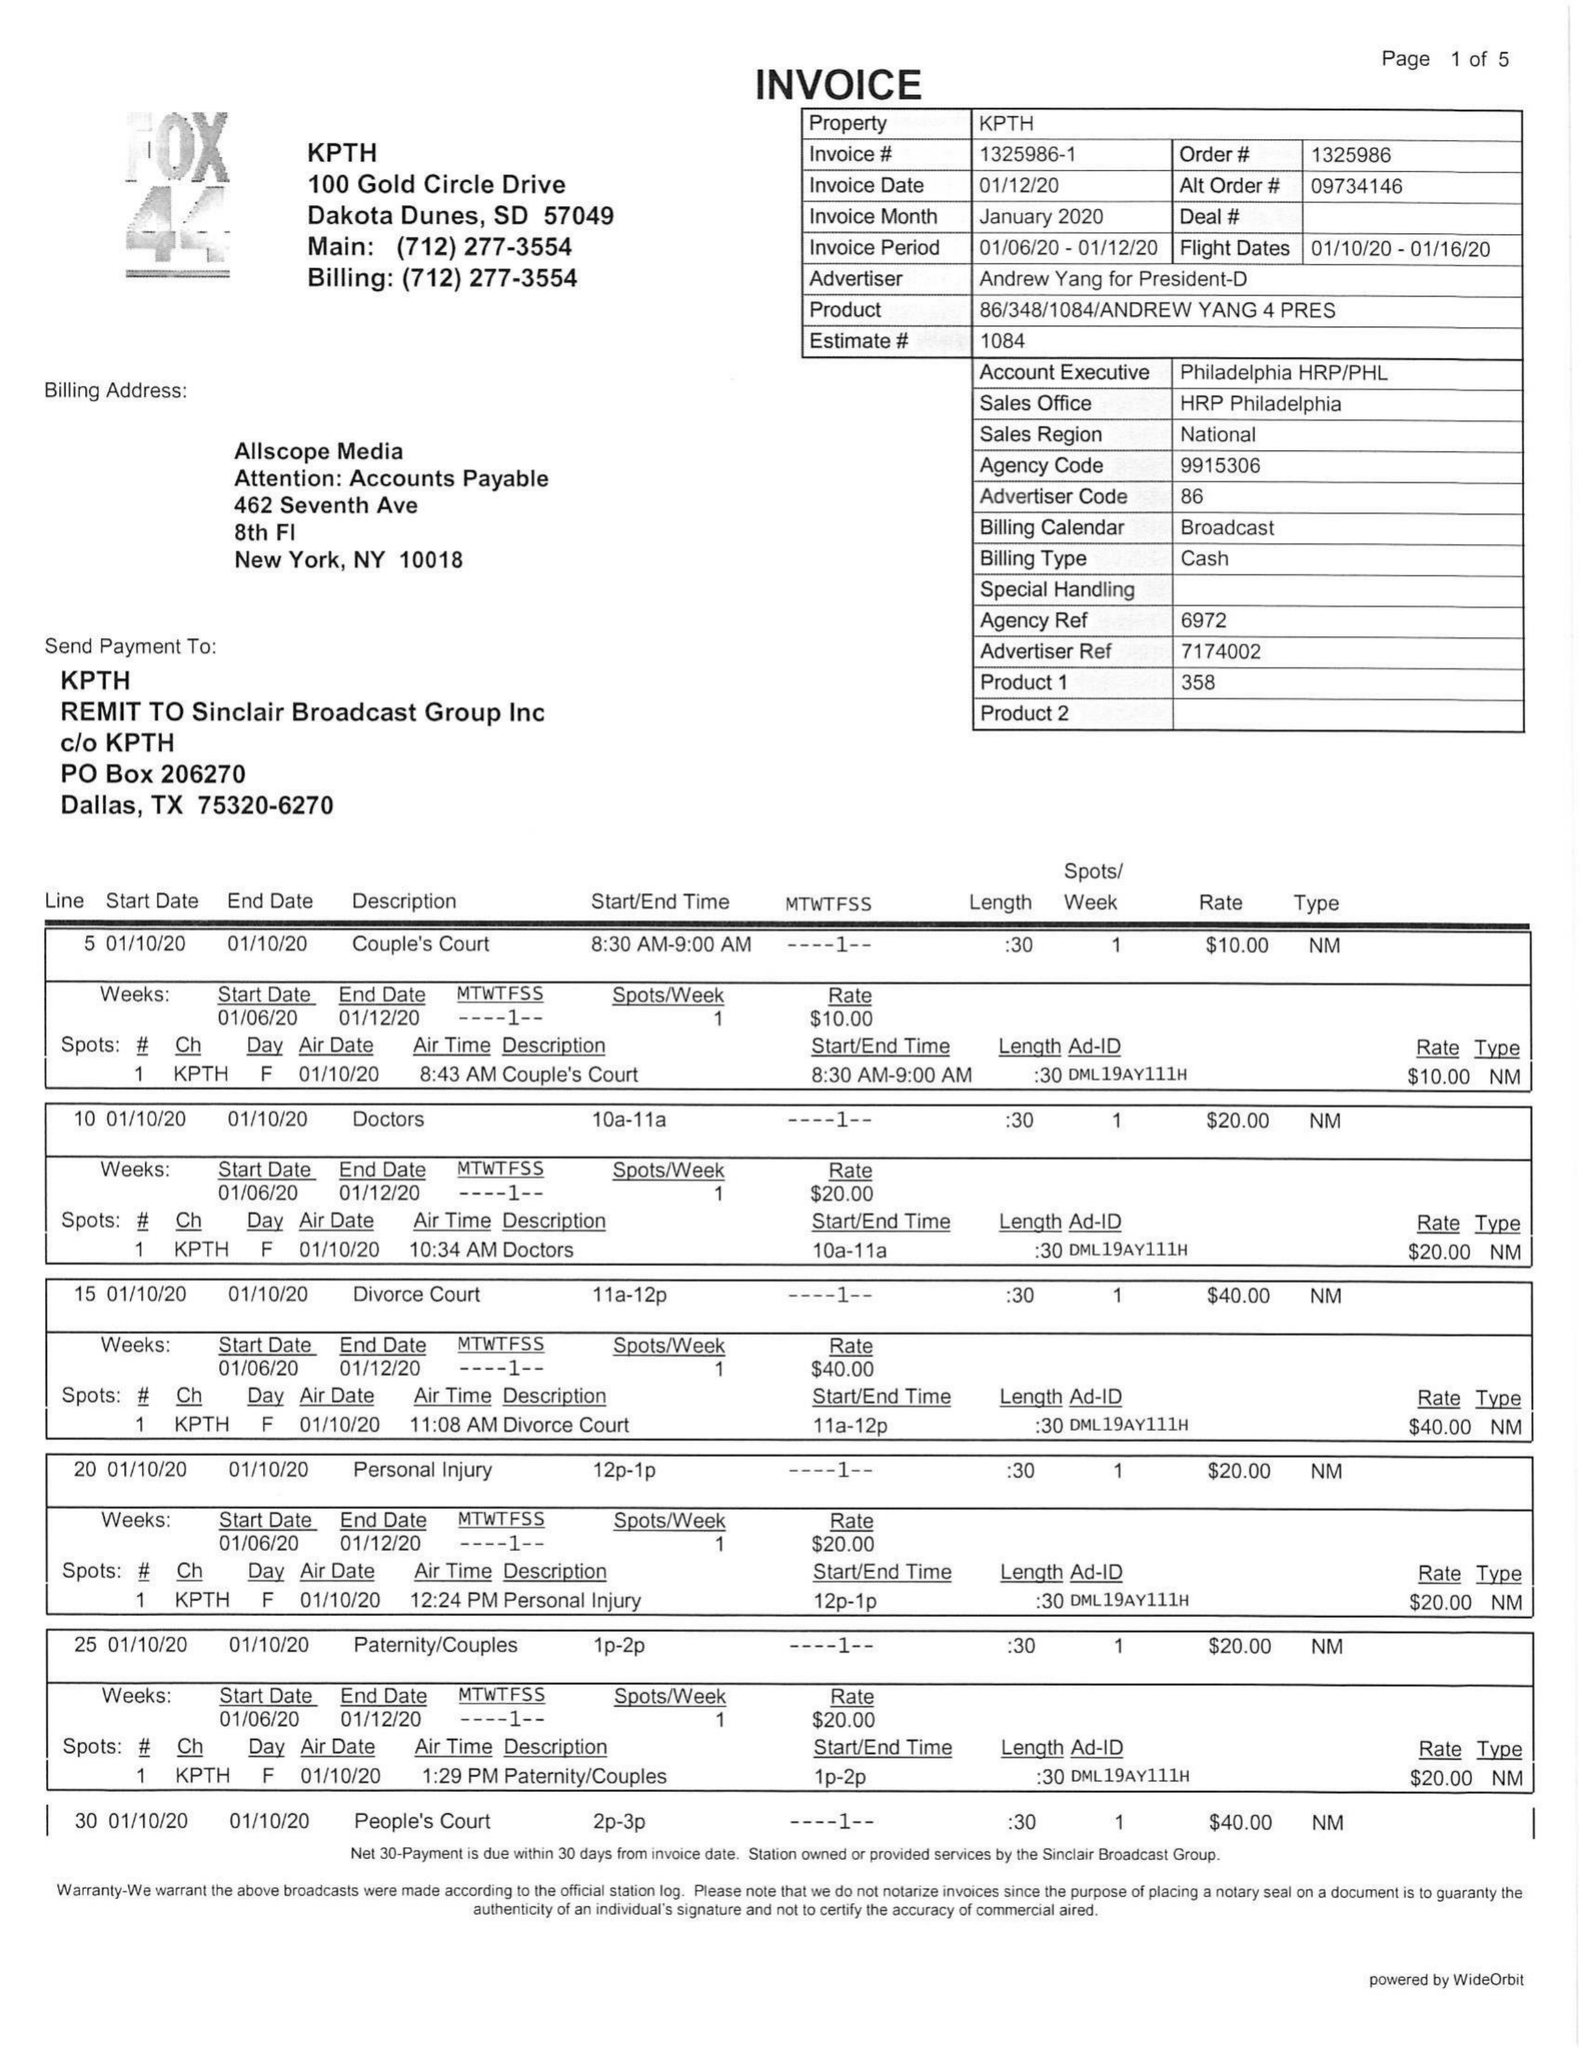What is the value for the flight_to?
Answer the question using a single word or phrase. 01/16/20 